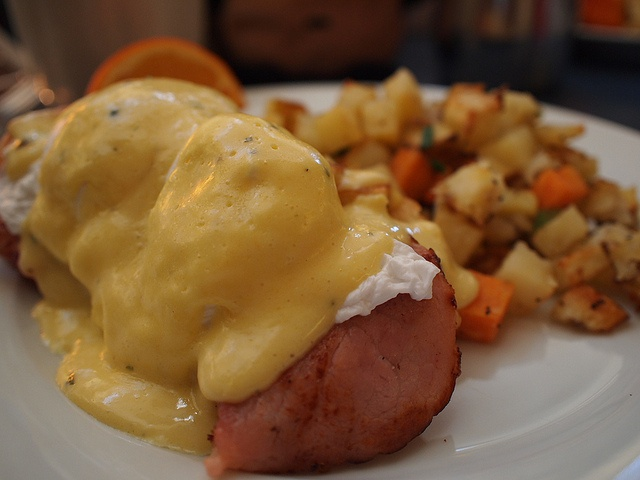Describe the objects in this image and their specific colors. I can see hot dog in black, maroon, and brown tones, orange in black, brown, and maroon tones, carrot in black, brown, and maroon tones, and carrot in black, maroon, and brown tones in this image. 